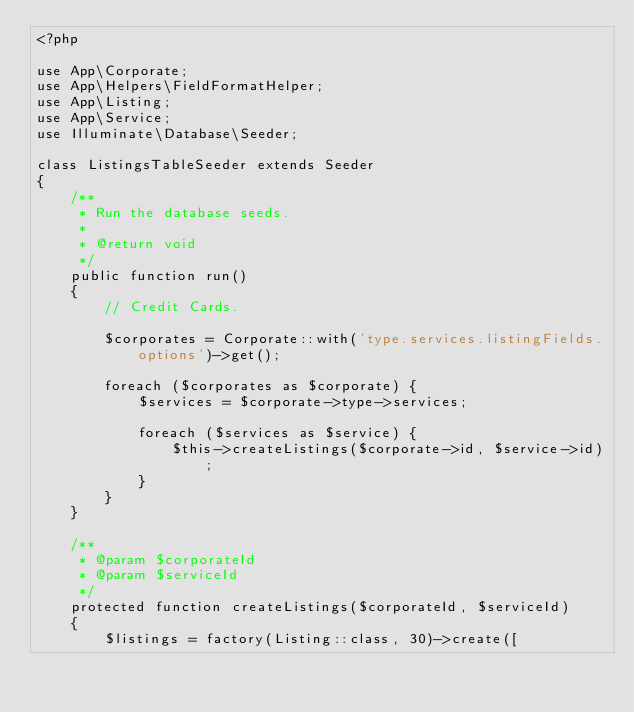Convert code to text. <code><loc_0><loc_0><loc_500><loc_500><_PHP_><?php

use App\Corporate;
use App\Helpers\FieldFormatHelper;
use App\Listing;
use App\Service;
use Illuminate\Database\Seeder;

class ListingsTableSeeder extends Seeder
{
    /**
     * Run the database seeds.
     *
     * @return void
     */
    public function run()
    {
        // Credit Cards.
        
        $corporates = Corporate::with('type.services.listingFields.options')->get();
        
        foreach ($corporates as $corporate) {
            $services = $corporate->type->services;
            
            foreach ($services as $service) {
                $this->createListings($corporate->id, $service->id);
            }
        }
    }

    /**
     * @param $corporateId
     * @param $serviceId
     */
    protected function createListings($corporateId, $serviceId)
    {
        $listings = factory(Listing::class, 30)->create([</code> 